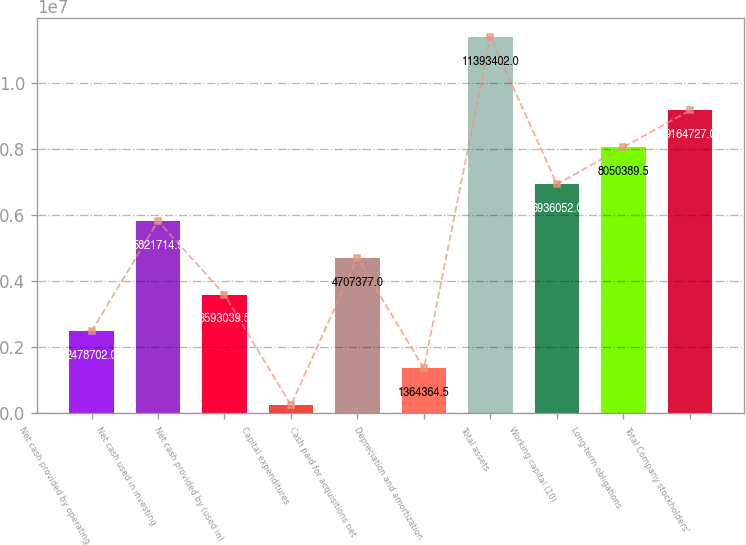Convert chart to OTSL. <chart><loc_0><loc_0><loc_500><loc_500><bar_chart><fcel>Net cash provided by operating<fcel>Net cash used in investing<fcel>Net cash provided by (used in)<fcel>Capital expenditures<fcel>Cash paid for acquisitions net<fcel>Depreciation and amortization<fcel>Total assets<fcel>Working capital (10)<fcel>Long-term obligations<fcel>Total Company stockholders'<nl><fcel>2.4787e+06<fcel>5.82171e+06<fcel>3.59304e+06<fcel>250027<fcel>4.70738e+06<fcel>1.36436e+06<fcel>1.13934e+07<fcel>6.93605e+06<fcel>8.05039e+06<fcel>9.16473e+06<nl></chart> 